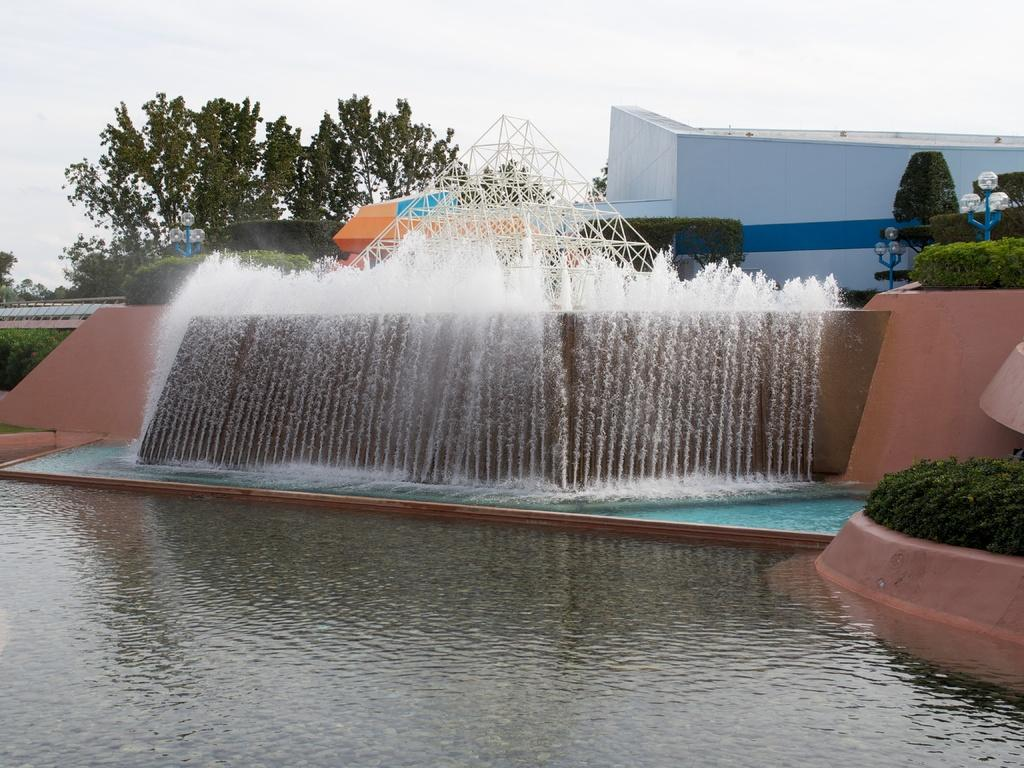What is the main feature in the image? There is a swimming pool in the image. Are there any additional features near the swimming pool? Yes, there is a fountain near the swimming pool. What can be seen in the background of the image? There are trees, a shed, and the sky visible in the background of the image. How many kittens are playing with paint near the shed in the image? There are no kittens or paint present in the image. 